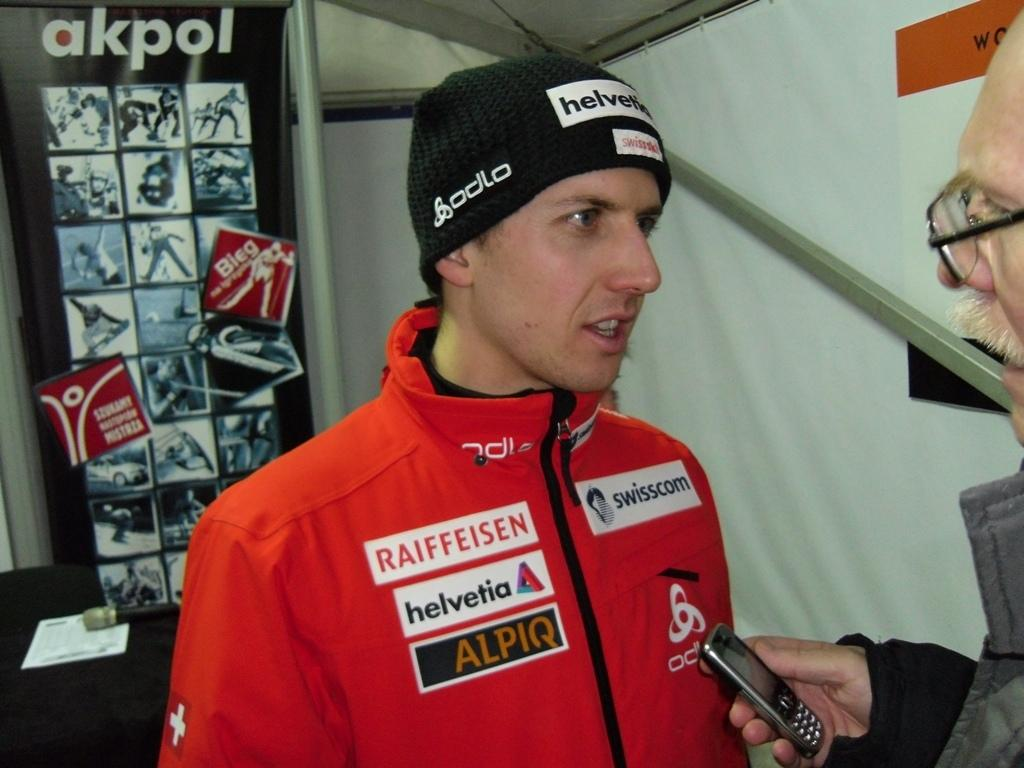<image>
Present a compact description of the photo's key features. The winter athlete is sponsored by Raiffeisen, Helvetica, and Alpiq. 